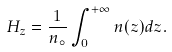Convert formula to latex. <formula><loc_0><loc_0><loc_500><loc_500>H _ { z } = \frac { 1 } { n _ { \circ } } \int _ { 0 } ^ { + \infty } n ( z ) d z .</formula> 